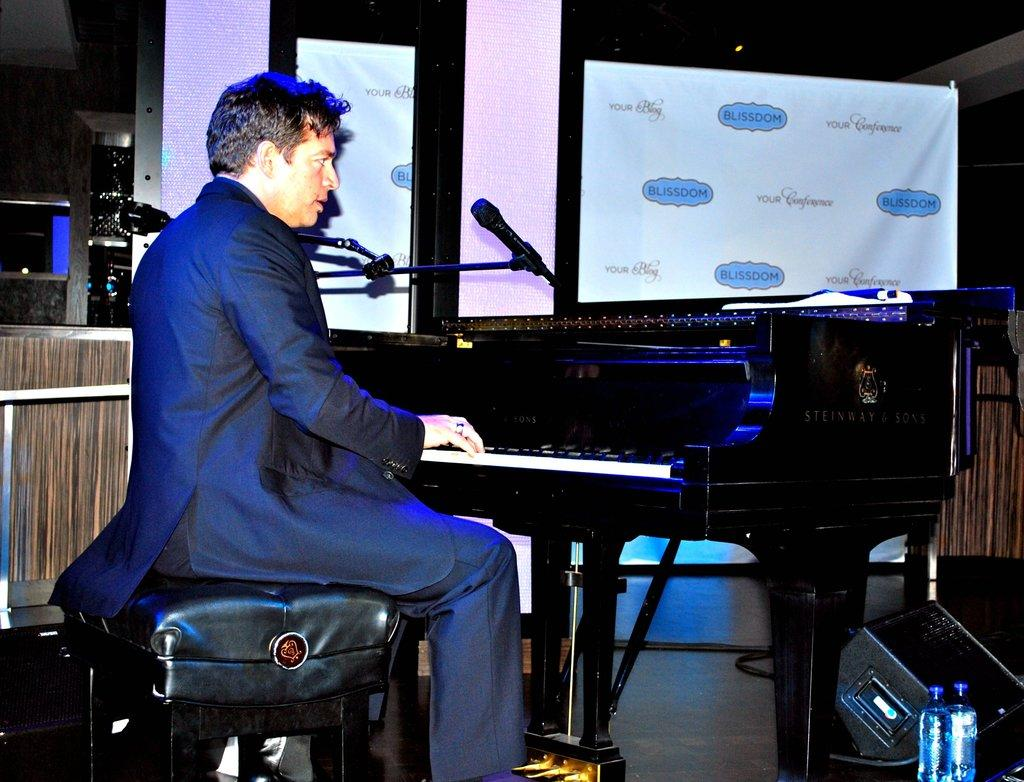What is the man in the image doing? The man is playing the piano in the image. What is the man wearing while playing the piano? The man is wearing a coat. Can you describe the man's position in the image? The man is sitting on a stool. What other object is present in the image related to the man's activity? There is a microphone in the image. What can be seen on the walls in the image? There are banners on the walls in the image. What type of tomatoes can be seen growing on the walls in the image? There are no tomatoes present in the image; the walls have banners on them. 